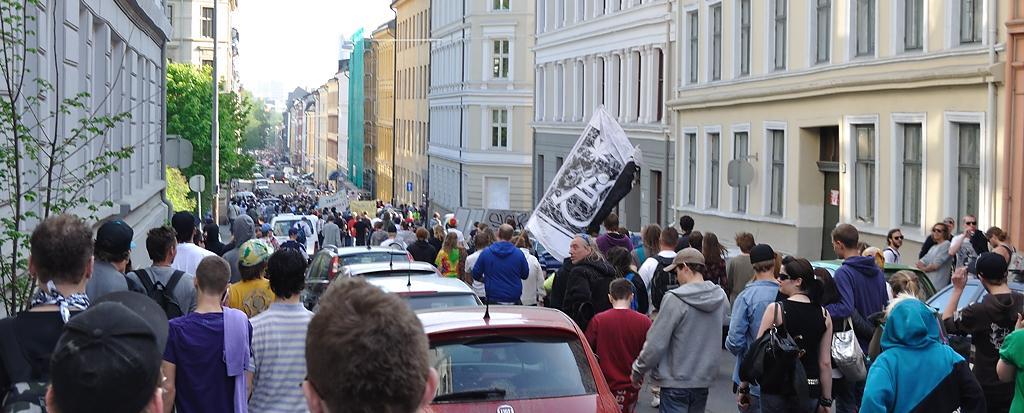Can you describe this image briefly? In this image I can see number of people and vehicles in the center and I see few of them are holding boards and banners. On the both side of this picture I can see the buildings and few trees. In the background I can see the sky. 